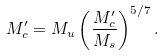<formula> <loc_0><loc_0><loc_500><loc_500>M ^ { \prime } _ { c } = M _ { u } \left ( \frac { M ^ { \prime } _ { c } } { M _ { s } } \right ) ^ { 5 / 7 } .</formula> 